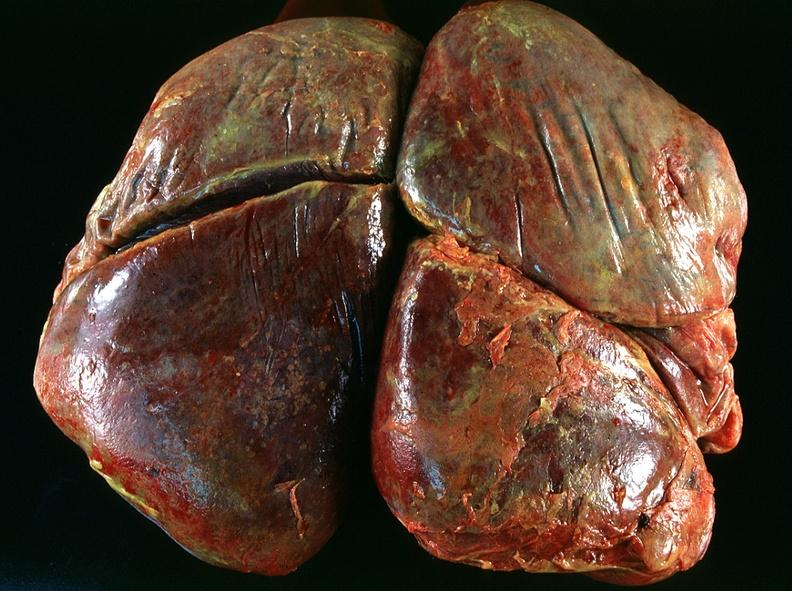where is this?
Answer the question using a single word or phrase. Lung 